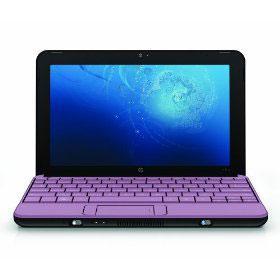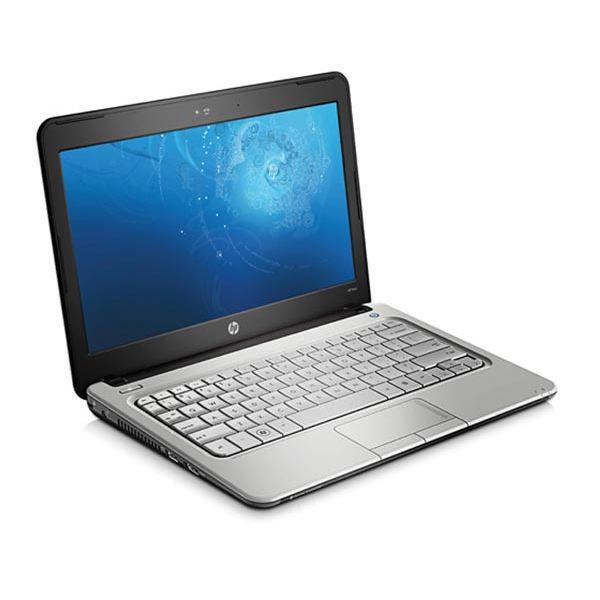The first image is the image on the left, the second image is the image on the right. Considering the images on both sides, is "The keyboard in the image on the left is black." valid? Answer yes or no. No. The first image is the image on the left, the second image is the image on the right. For the images displayed, is the sentence "One open laptop faces straight forward, and the other is turned at an angle but not held by a hand." factually correct? Answer yes or no. Yes. 